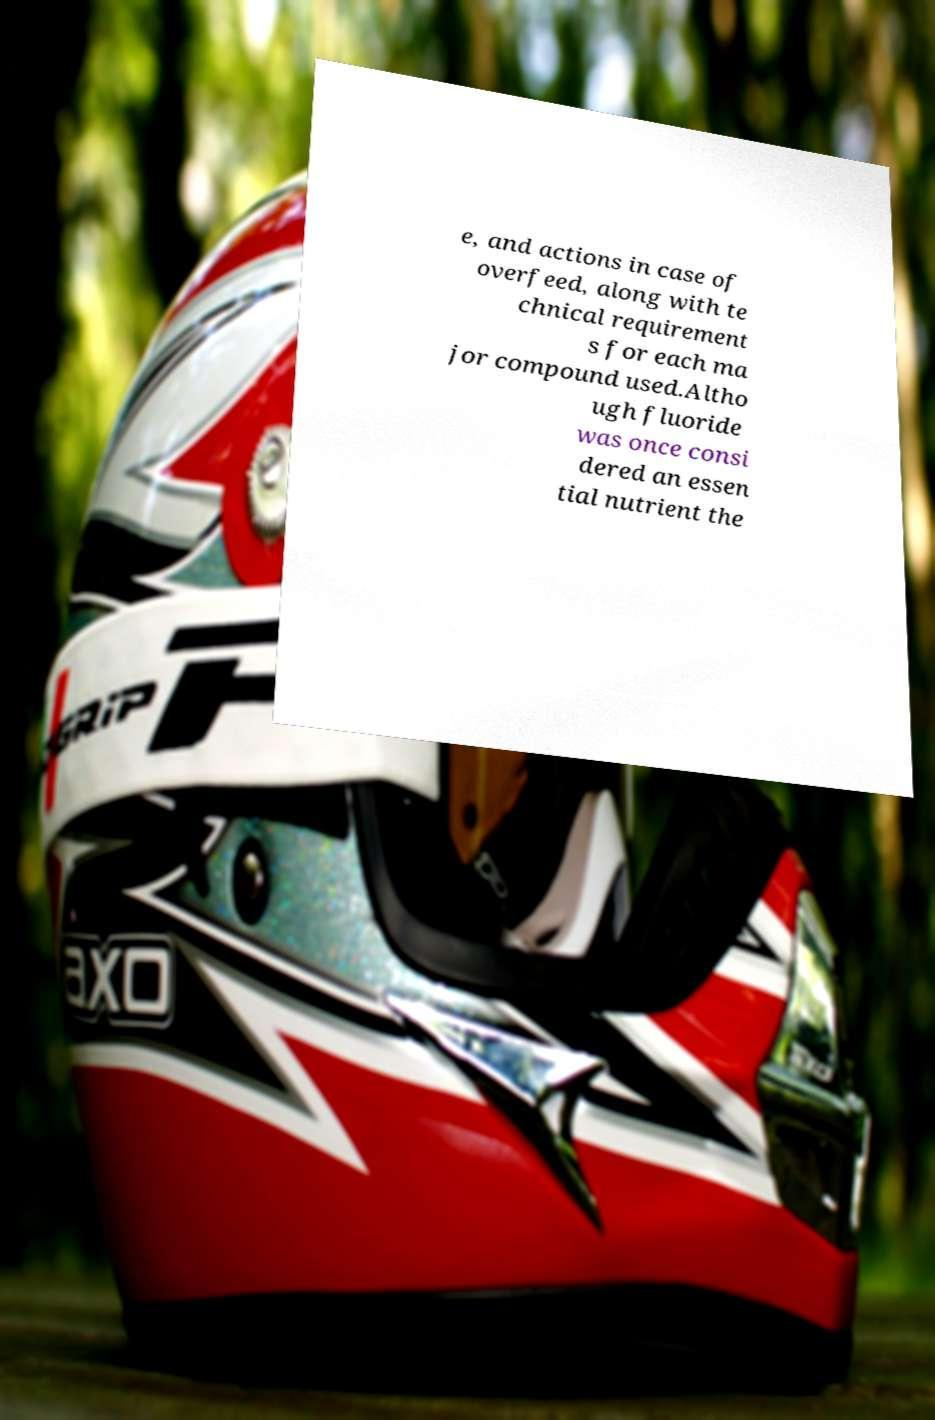Could you assist in decoding the text presented in this image and type it out clearly? e, and actions in case of overfeed, along with te chnical requirement s for each ma jor compound used.Altho ugh fluoride was once consi dered an essen tial nutrient the 